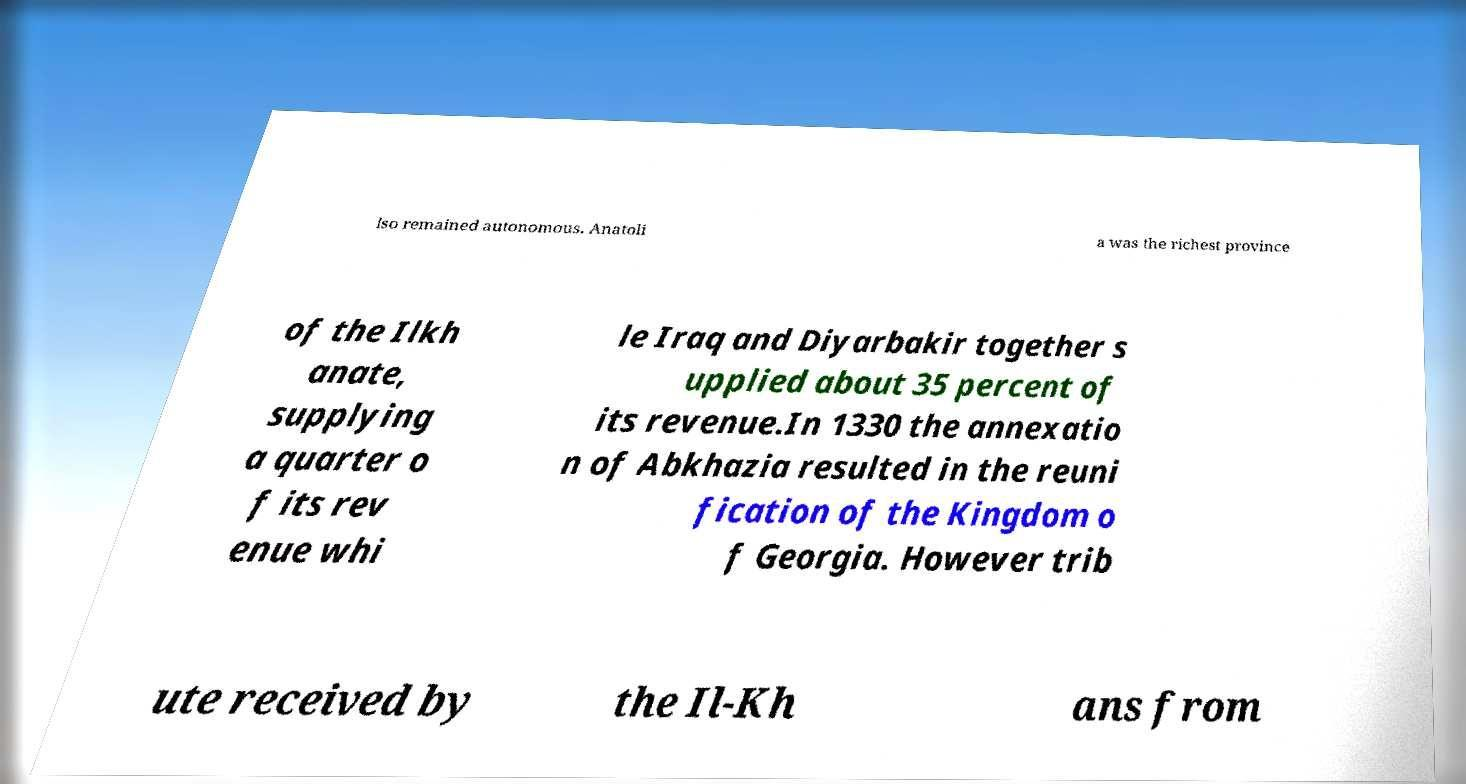Can you accurately transcribe the text from the provided image for me? lso remained autonomous. Anatoli a was the richest province of the Ilkh anate, supplying a quarter o f its rev enue whi le Iraq and Diyarbakir together s upplied about 35 percent of its revenue.In 1330 the annexatio n of Abkhazia resulted in the reuni fication of the Kingdom o f Georgia. However trib ute received by the Il-Kh ans from 